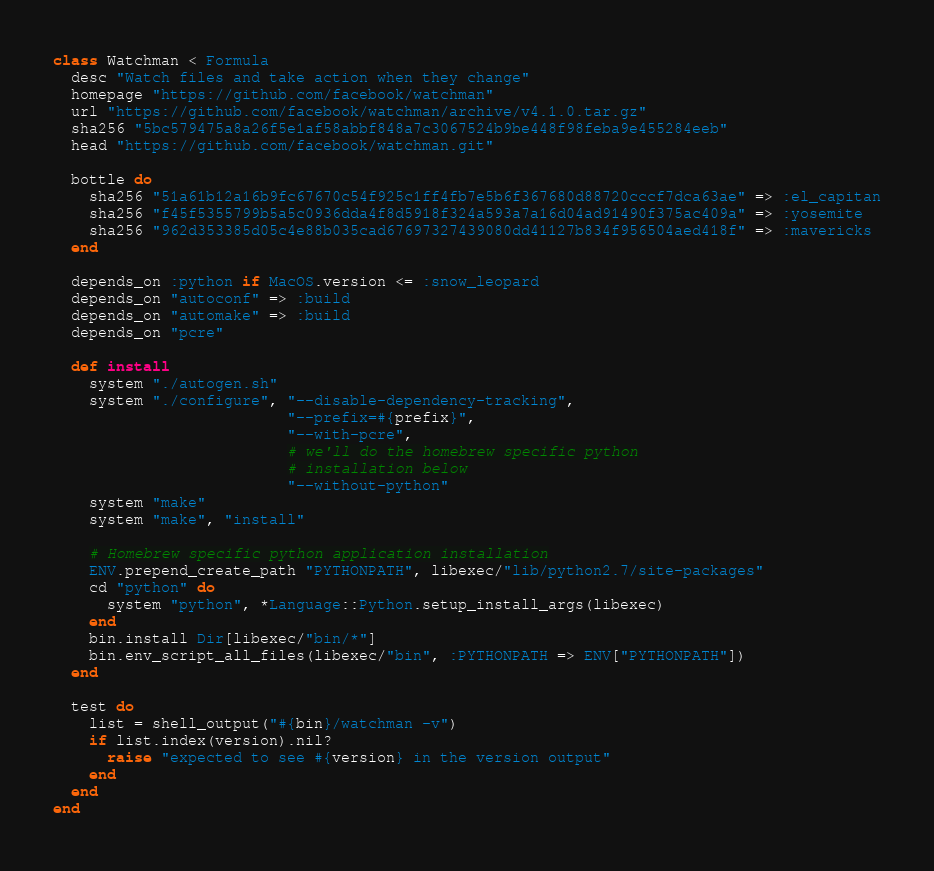Convert code to text. <code><loc_0><loc_0><loc_500><loc_500><_Ruby_>class Watchman < Formula
  desc "Watch files and take action when they change"
  homepage "https://github.com/facebook/watchman"
  url "https://github.com/facebook/watchman/archive/v4.1.0.tar.gz"
  sha256 "5bc579475a8a26f5e1af58abbf848a7c3067524b9be448f98feba9e455284eeb"
  head "https://github.com/facebook/watchman.git"

  bottle do
    sha256 "51a61b12a16b9fc67670c54f925c1ff4fb7e5b6f367680d88720cccf7dca63ae" => :el_capitan
    sha256 "f45f5355799b5a5c0936dda4f8d5918f324a593a7a16d04ad91490f375ac409a" => :yosemite
    sha256 "962d353385d05c4e88b035cad67697327439080dd41127b834f956504aed418f" => :mavericks
  end

  depends_on :python if MacOS.version <= :snow_leopard
  depends_on "autoconf" => :build
  depends_on "automake" => :build
  depends_on "pcre"

  def install
    system "./autogen.sh"
    system "./configure", "--disable-dependency-tracking",
                          "--prefix=#{prefix}",
                          "--with-pcre",
                          # we'll do the homebrew specific python
                          # installation below
                          "--without-python"
    system "make"
    system "make", "install"

    # Homebrew specific python application installation
    ENV.prepend_create_path "PYTHONPATH", libexec/"lib/python2.7/site-packages"
    cd "python" do
      system "python", *Language::Python.setup_install_args(libexec)
    end
    bin.install Dir[libexec/"bin/*"]
    bin.env_script_all_files(libexec/"bin", :PYTHONPATH => ENV["PYTHONPATH"])
  end

  test do
    list = shell_output("#{bin}/watchman -v")
    if list.index(version).nil?
      raise "expected to see #{version} in the version output"
    end
  end
end
</code> 